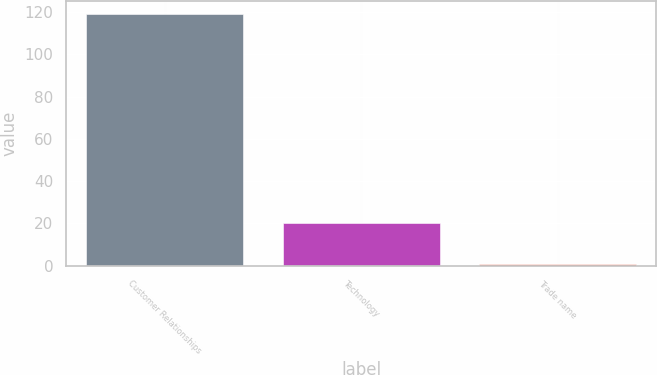Convert chart. <chart><loc_0><loc_0><loc_500><loc_500><bar_chart><fcel>Customer Relationships<fcel>Technology<fcel>Trade name<nl><fcel>119<fcel>20<fcel>1<nl></chart> 